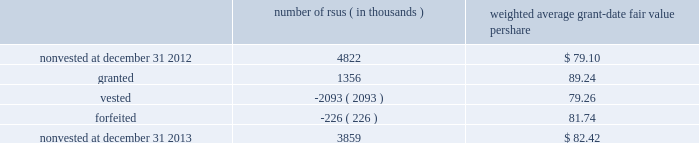Note 12 2013 stock-based compensation during 2013 , 2012 , and 2011 , we recorded non-cash stock-based compensation expense totaling $ 189 million , $ 167 million , and $ 157 million , which is included as a component of other unallocated costs on our statements of earnings .
The net impact to earnings for the respective years was $ 122 million , $ 108 million , and $ 101 million .
As of december 31 , 2013 , we had $ 132 million of unrecognized compensation cost related to nonvested awards , which is expected to be recognized over a weighted average period of 1.5 years .
We received cash from the exercise of stock options totaling $ 827 million , $ 440 million , and $ 116 million during 2013 , 2012 , and 2011 .
In addition , our income tax liabilities for 2013 , 2012 , and 2011 were reduced by $ 158 million , $ 96 million , and $ 56 million due to recognized tax benefits on stock-based compensation arrangements .
Stock-based compensation plans under plans approved by our stockholders , we are authorized to grant key employees stock-based incentive awards , including options to purchase common stock , stock appreciation rights , restricted stock units ( rsus ) , performance stock units ( psus ) , or other stock units .
The exercise price of options to purchase common stock may not be less than the fair market value of our stock on the date of grant .
No award of stock options may become fully vested prior to the third anniversary of the grant , and no portion of a stock option grant may become vested in less than one year .
The minimum vesting period for restricted stock or stock units payable in stock is three years .
Award agreements may provide for shorter or pro-rated vesting periods or vesting following termination of employment in the case of death , disability , divestiture , retirement , change of control , or layoff .
The maximum term of a stock option or any other award is 10 years .
At december 31 , 2013 , inclusive of the shares reserved for outstanding stock options , rsus and psus , we had 20.4 million shares reserved for issuance under the plans .
At december 31 , 2013 , 4.7 million of the shares reserved for issuance remained available for grant under our stock-based compensation plans .
We issue new shares upon the exercise of stock options or when restrictions on rsus and psus have been satisfied .
The table summarizes activity related to nonvested rsus during 2013 : number of rsus ( in thousands ) weighted average grant-date fair value per share .
Rsus are valued based on the fair value of our common stock on the date of grant .
Employees who are granted rsus receive the right to receive shares of stock after completion of the vesting period , however , the shares are not issued , and the employees cannot sell or transfer shares prior to vesting and have no voting rights until the rsus vest , generally three years from the date of the award .
Employees who are granted rsus receive dividend-equivalent cash payments only upon vesting .
For these rsu awards , the grant-date fair value is equal to the closing market price of our common stock on the date of grant less a discount to reflect the delay in payment of dividend-equivalent cash payments .
We recognize the grant-date fair value of rsus , less estimated forfeitures , as compensation expense ratably over the requisite service period , which beginning with the rsus granted in 2013 is shorter than the vesting period if the employee is retirement eligible on the date of grant or will become retirement eligible before the end of the vesting period .
Stock options we generally recognize compensation cost for stock options ratably over the three-year vesting period .
At december 31 , 2013 and 2012 , there were 10.2 million ( weighted average exercise price of $ 83.65 ) and 20.6 million ( weighted average exercise price of $ 83.15 ) stock options outstanding .
Stock options outstanding at december 31 , 2013 have a weighted average remaining contractual life of approximately five years and an aggregate intrinsic value of $ 663 million , and we expect nearly all of these stock options to vest .
Of the stock options outstanding , 7.7 million ( weighted average exercise price of $ 84.37 ) have vested as of december 31 , 2013 and those stock options have a weighted average remaining contractual life of approximately four years and an aggregate intrinsic value of $ 497 million .
There were 10.1 million ( weighted average exercise price of $ 82.72 ) stock options exercised during 2013 .
We did not grant stock options to employees during 2013. .
What was the percentage change in the number of rsus outstanding from 2012 to 2013? 
Computations: ((3859 - 4822) / 4822)
Answer: -0.19971. 